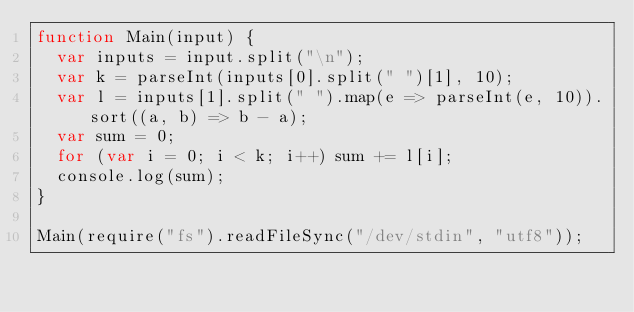Convert code to text. <code><loc_0><loc_0><loc_500><loc_500><_JavaScript_>function Main(input) {
  var inputs = input.split("\n");
  var k = parseInt(inputs[0].split(" ")[1], 10);
  var l = inputs[1].split(" ").map(e => parseInt(e, 10)).sort((a, b) => b - a);
  var sum = 0;
  for (var i = 0; i < k; i++) sum += l[i];
  console.log(sum);
}

Main(require("fs").readFileSync("/dev/stdin", "utf8"));</code> 